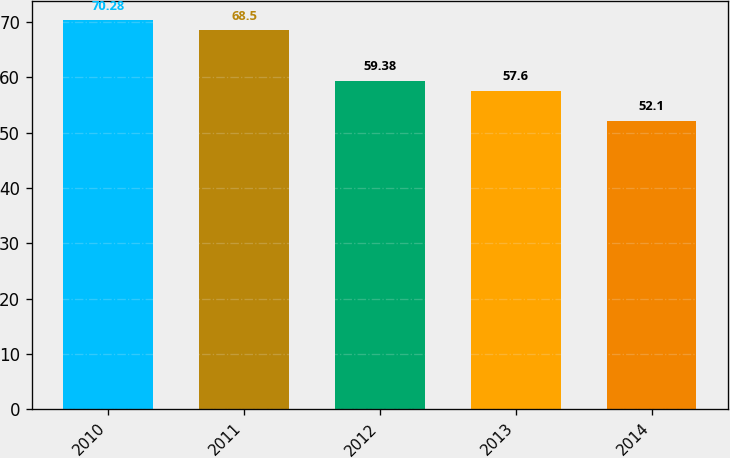Convert chart. <chart><loc_0><loc_0><loc_500><loc_500><bar_chart><fcel>2010<fcel>2011<fcel>2012<fcel>2013<fcel>2014<nl><fcel>70.28<fcel>68.5<fcel>59.38<fcel>57.6<fcel>52.1<nl></chart> 